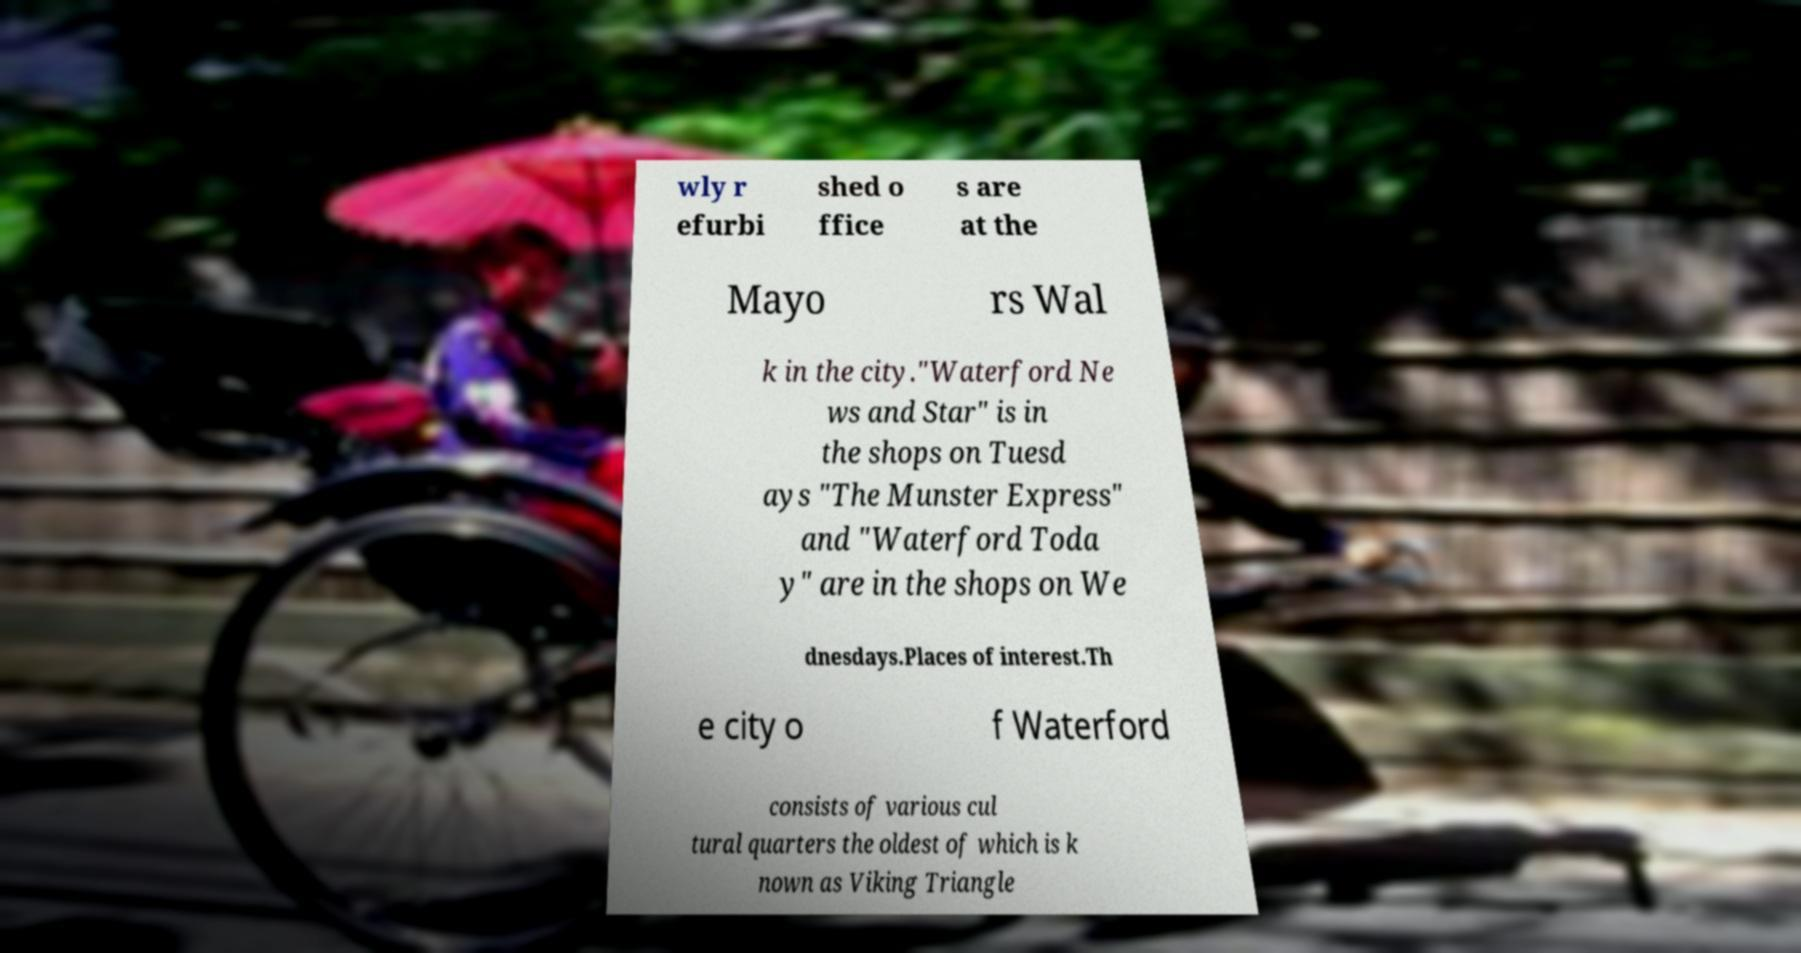Could you extract and type out the text from this image? wly r efurbi shed o ffice s are at the Mayo rs Wal k in the city."Waterford Ne ws and Star" is in the shops on Tuesd ays "The Munster Express" and "Waterford Toda y" are in the shops on We dnesdays.Places of interest.Th e city o f Waterford consists of various cul tural quarters the oldest of which is k nown as Viking Triangle 